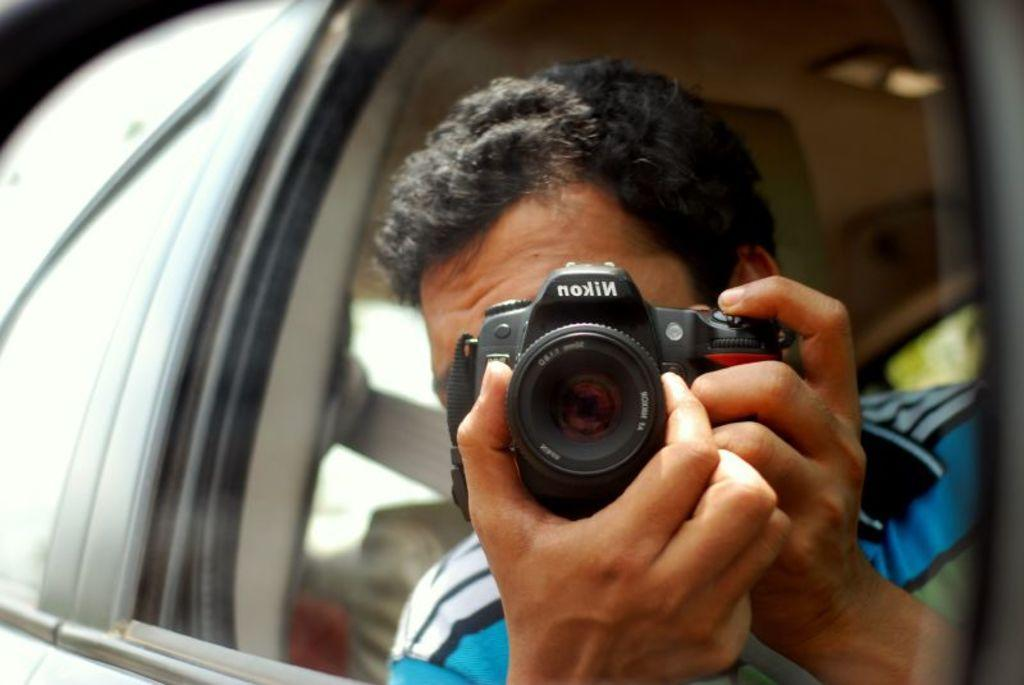What is the man in the image doing? The man is taking a picture. Where is the man sitting in the image? The man is sitting in a car near the window seat. What is the man wearing in the image? The man is wearing a blue and white striped t-shirt. What object is the man holding in the image? The man is holding a Nikon camera. What type of bread is the man eating in the image? There is no bread present in the image; the man is holding a Nikon camera and taking a picture. What is the man's discovery in the image? There is no mention of a discovery in the image; the man is simply taking a picture. 